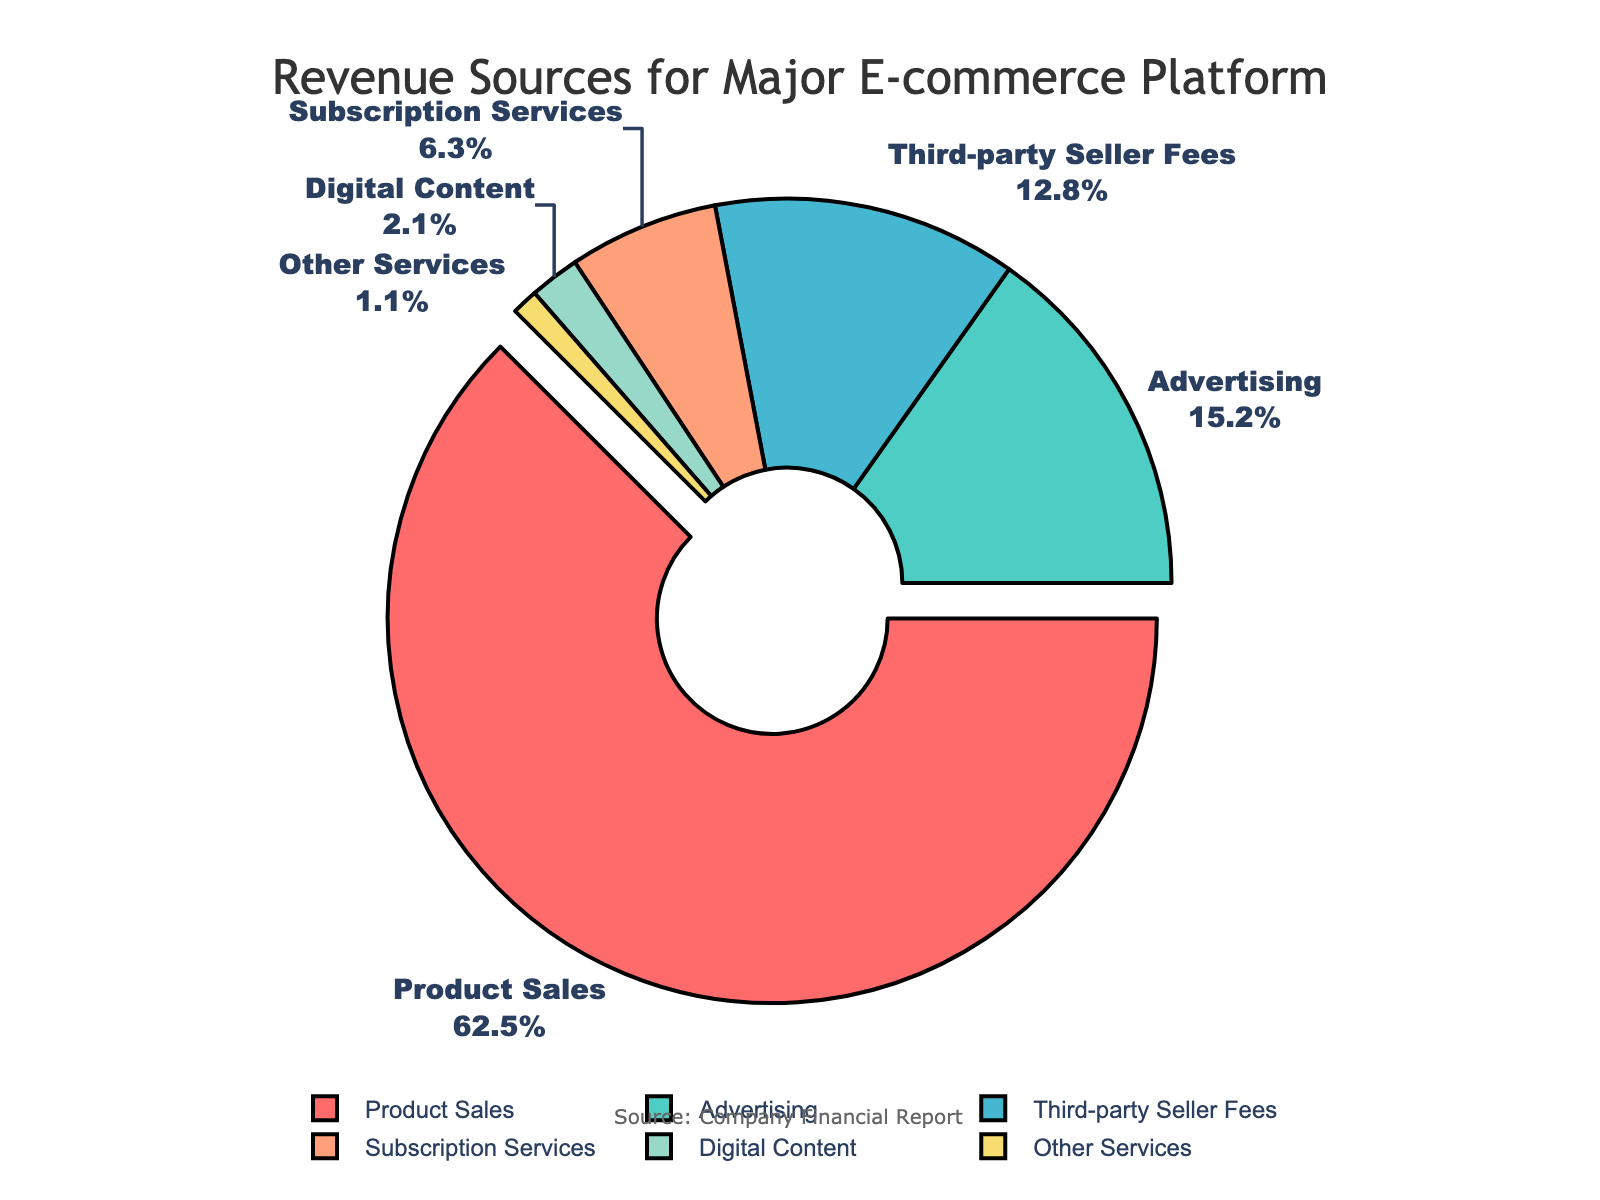What percentage of the total revenue comes from the top two sources combined? The top two sources are "Product Sales" and "Advertising". They contribute 62.5% and 15.2% respectively. Summing them up gives 62.5% + 15.2% = 77.7%.
Answer: 77.7% Which source contributes the least to the revenue? By looking at the chart, "Other Services" is the smallest segment, indicating it contributes the least.
Answer: Other Services What is the difference in revenue percentage between Third-party Seller Fees and Subscription Services? Third-party Seller Fees contribute 12.8%, and Subscription Services contribute 6.3%. The difference is 12.8% - 6.3% = 6.5%.
Answer: 6.5% If the revenue from Digital Content doubled, what would its new percentage be? The current percentage from Digital Content is 2.1%. Doubling this would result in 2.1% * 2 = 4.2%.
Answer: 4.2% How much more does Product Sales contribute to the revenue compared to Advertising? Product Sales contribute 62.5%, while Advertising contributes 15.2%. The difference is 62.5% - 15.2% = 47.3%.
Answer: 47.3% Which two sources have the closest contribution percentages? By comparing the contributions, "Third-party Seller Fees" (12.8%) and "Subscription Services" (6.3%) have the closest values, with a difference of 12.8% - 6.3% = 6.5%.
Answer: Third-party Seller Fees and Subscription Services What is the combined percentage of revenue from sources other than Product Sales? The contributions from sources other than Product Sales are 15.2% (Advertising), 12.8% (Third-party Seller Fees), 6.3% (Subscription Services), 2.1% (Digital Content), and 1.1% (Other Services). Sum them up: 15.2% + 12.8% + 6.3% + 2.1% + 1.1% = 37.5%.
Answer: 37.5% Identify the section of the chart with a red color. In the chart, "Product Sales" is represented by the red color.
Answer: Product Sales Which source is pulled out from the pie chart and why could this visual differentiation be useful? "Product Sales" is pulled out from the chart. This could highlight its significance as the major contributor to the revenue.
Answer: Product Sales 